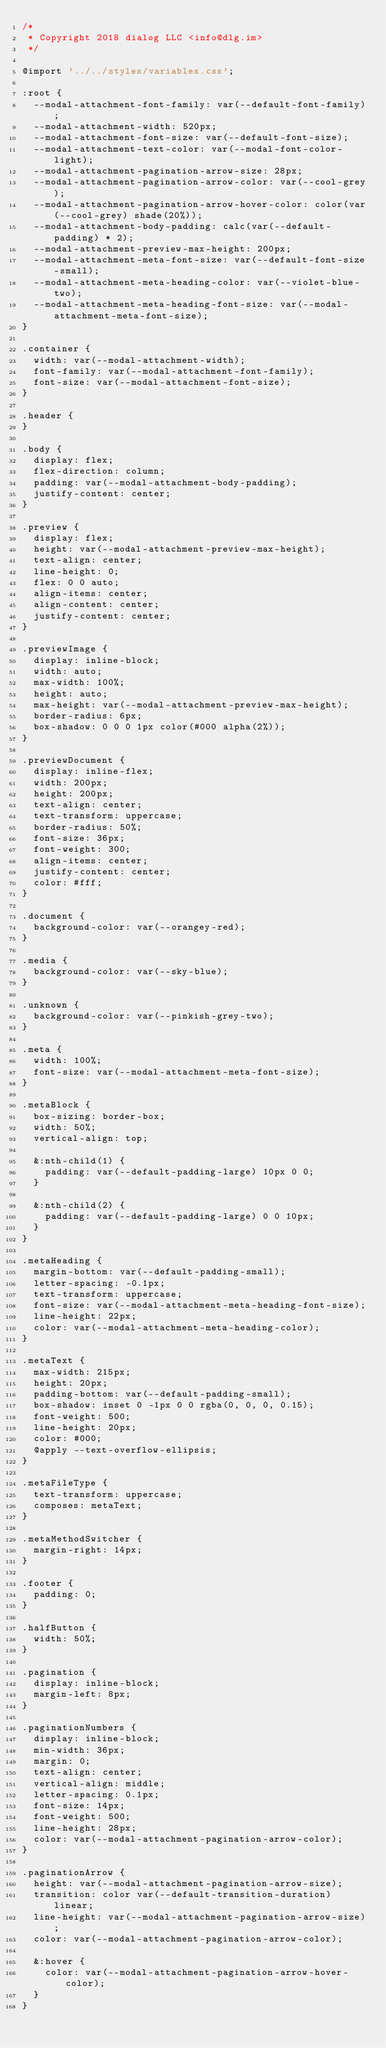Convert code to text. <code><loc_0><loc_0><loc_500><loc_500><_CSS_>/*
 * Copyright 2018 dialog LLC <info@dlg.im>
 */

@import '../../styles/variables.css';

:root {
  --modal-attachment-font-family: var(--default-font-family);
  --modal-attachment-width: 520px;
  --modal-attachment-font-size: var(--default-font-size);
  --modal-attachment-text-color: var(--modal-font-color-light);
  --modal-attachment-pagination-arrow-size: 28px;
  --modal-attachment-pagination-arrow-color: var(--cool-grey);
  --modal-attachment-pagination-arrow-hover-color: color(var(--cool-grey) shade(20%));
  --modal-attachment-body-padding: calc(var(--default-padding) * 2);
  --modal-attachment-preview-max-height: 200px;
  --modal-attachment-meta-font-size: var(--default-font-size-small);
  --modal-attachment-meta-heading-color: var(--violet-blue-two);
  --modal-attachment-meta-heading-font-size: var(--modal-attachment-meta-font-size);
}

.container {
  width: var(--modal-attachment-width);
  font-family: var(--modal-attachment-font-family);
  font-size: var(--modal-attachment-font-size);
}

.header {
}

.body {
  display: flex;
  flex-direction: column;
  padding: var(--modal-attachment-body-padding);
  justify-content: center;
}

.preview {
  display: flex;
  height: var(--modal-attachment-preview-max-height);
  text-align: center;
  line-height: 0;
  flex: 0 0 auto;
  align-items: center;
  align-content: center;
  justify-content: center;
}

.previewImage {
  display: inline-block;
  width: auto;
  max-width: 100%;
  height: auto;
  max-height: var(--modal-attachment-preview-max-height);
  border-radius: 6px;
  box-shadow: 0 0 0 1px color(#000 alpha(2%));
}

.previewDocument {
  display: inline-flex;
  width: 200px;
  height: 200px;
  text-align: center;
  text-transform: uppercase;
  border-radius: 50%;
  font-size: 36px;
  font-weight: 300;
  align-items: center;
  justify-content: center;
  color: #fff;
}

.document {
  background-color: var(--orangey-red);
}

.media {
  background-color: var(--sky-blue);
}

.unknown {
  background-color: var(--pinkish-grey-two);
}

.meta {
  width: 100%;
  font-size: var(--modal-attachment-meta-font-size);
}

.metaBlock {
  box-sizing: border-box;
  width: 50%;
  vertical-align: top;

  &:nth-child(1) {
    padding: var(--default-padding-large) 10px 0 0;
  }

  &:nth-child(2) {
    padding: var(--default-padding-large) 0 0 10px;
  }
}

.metaHeading {
  margin-bottom: var(--default-padding-small);
  letter-spacing: -0.1px;
  text-transform: uppercase;
  font-size: var(--modal-attachment-meta-heading-font-size);
  line-height: 22px;
  color: var(--modal-attachment-meta-heading-color);
}

.metaText {
  max-width: 215px;
  height: 20px;
  padding-bottom: var(--default-padding-small);
  box-shadow: inset 0 -1px 0 0 rgba(0, 0, 0, 0.15);
  font-weight: 500;
  line-height: 20px;
  color: #000;
  @apply --text-overflow-ellipsis;
}

.metaFileType {
  text-transform: uppercase;
  composes: metaText;
}

.metaMethodSwitcher {
  margin-right: 14px;
}

.footer {
  padding: 0;
}

.halfButton {
  width: 50%;
}

.pagination {
  display: inline-block;
  margin-left: 8px;
}

.paginationNumbers {
  display: inline-block;
  min-width: 36px;
  margin: 0;
  text-align: center;
  vertical-align: middle;
  letter-spacing: 0.1px;
  font-size: 14px;
  font-weight: 500;
  line-height: 28px;
  color: var(--modal-attachment-pagination-arrow-color);
}

.paginationArrow {
  height: var(--modal-attachment-pagination-arrow-size);
  transition: color var(--default-transition-duration) linear;
  line-height: var(--modal-attachment-pagination-arrow-size);
  color: var(--modal-attachment-pagination-arrow-color);

  &:hover {
    color: var(--modal-attachment-pagination-arrow-hover-color);
  }
}
</code> 